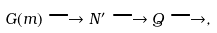<formula> <loc_0><loc_0><loc_500><loc_500>G ( m ) \longrightarrow N ^ { \prime } \longrightarrow Q \longrightarrow ,</formula> 